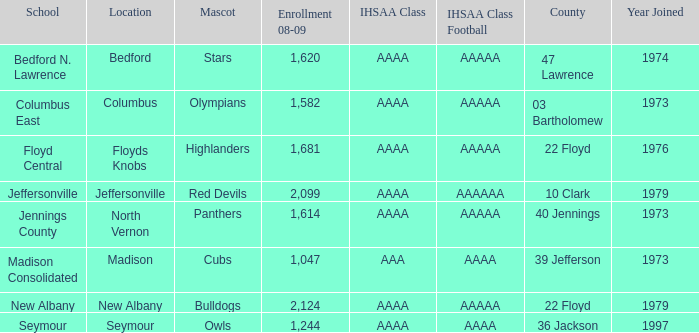What school is in 36 Jackson? Seymour. 